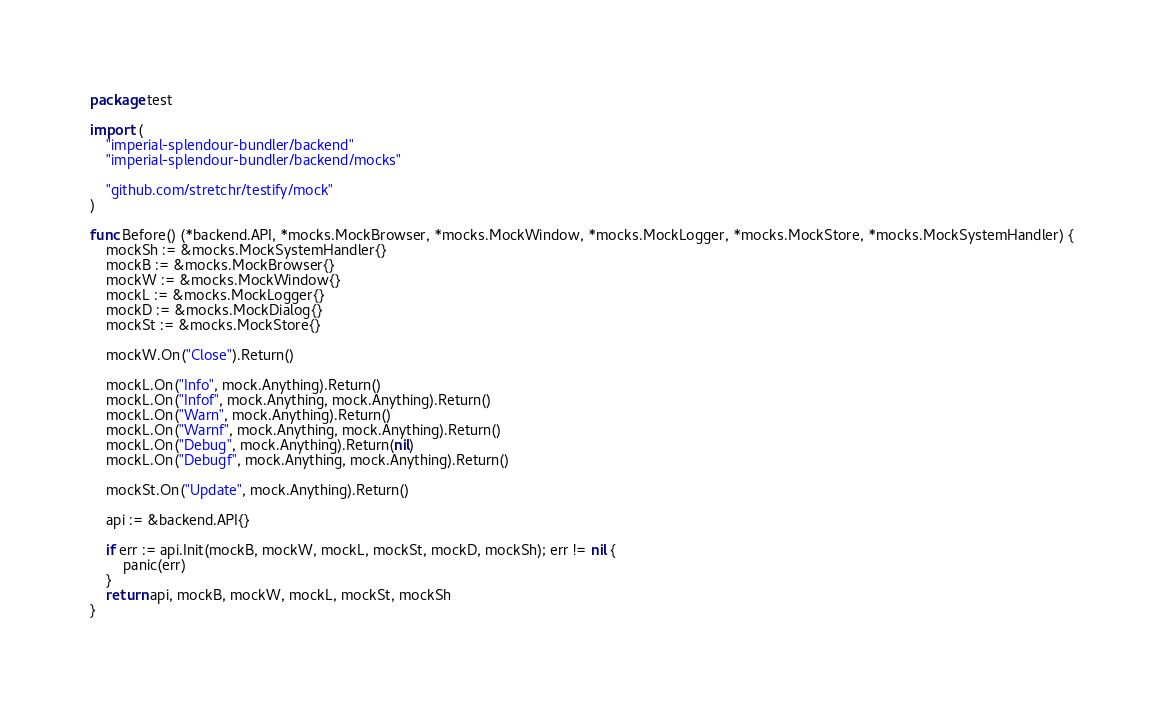<code> <loc_0><loc_0><loc_500><loc_500><_Go_>package test

import (
	"imperial-splendour-bundler/backend"
	"imperial-splendour-bundler/backend/mocks"

	"github.com/stretchr/testify/mock"
)

func Before() (*backend.API, *mocks.MockBrowser, *mocks.MockWindow, *mocks.MockLogger, *mocks.MockStore, *mocks.MockSystemHandler) {
	mockSh := &mocks.MockSystemHandler{}
	mockB := &mocks.MockBrowser{}
	mockW := &mocks.MockWindow{}
	mockL := &mocks.MockLogger{}
	mockD := &mocks.MockDialog{}
	mockSt := &mocks.MockStore{}

	mockW.On("Close").Return()

	mockL.On("Info", mock.Anything).Return()
	mockL.On("Infof", mock.Anything, mock.Anything).Return()
	mockL.On("Warn", mock.Anything).Return()
	mockL.On("Warnf", mock.Anything, mock.Anything).Return()
	mockL.On("Debug", mock.Anything).Return(nil)
	mockL.On("Debugf", mock.Anything, mock.Anything).Return()

	mockSt.On("Update", mock.Anything).Return()

	api := &backend.API{}

	if err := api.Init(mockB, mockW, mockL, mockSt, mockD, mockSh); err != nil {
		panic(err)
	}
	return api, mockB, mockW, mockL, mockSt, mockSh
}
</code> 